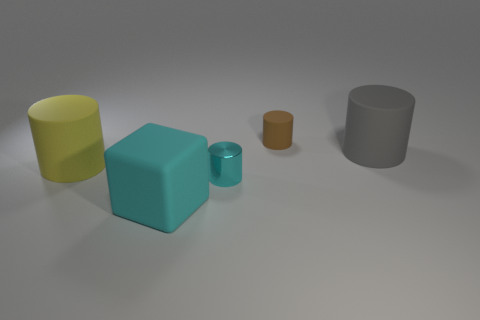Are there the same number of yellow matte cylinders in front of the metal thing and tiny red spheres?
Provide a short and direct response. Yes. Does the cube have the same size as the brown cylinder?
Your answer should be very brief. No. The thing that is in front of the large yellow rubber thing and to the right of the large cyan matte block is made of what material?
Offer a very short reply. Metal. How many small red objects are the same shape as the large gray thing?
Keep it short and to the point. 0. What material is the cyan thing that is to the right of the cube?
Make the answer very short. Metal. Is the number of brown objects in front of the big cyan matte cube less than the number of cyan matte cubes?
Keep it short and to the point. Yes. Is the brown thing the same shape as the gray thing?
Ensure brevity in your answer.  Yes. Is there anything else that has the same shape as the yellow rubber thing?
Make the answer very short. Yes. Is there a rubber thing?
Your answer should be compact. Yes. There is a gray thing; does it have the same shape as the big matte thing that is in front of the small cyan shiny cylinder?
Your response must be concise. No. 